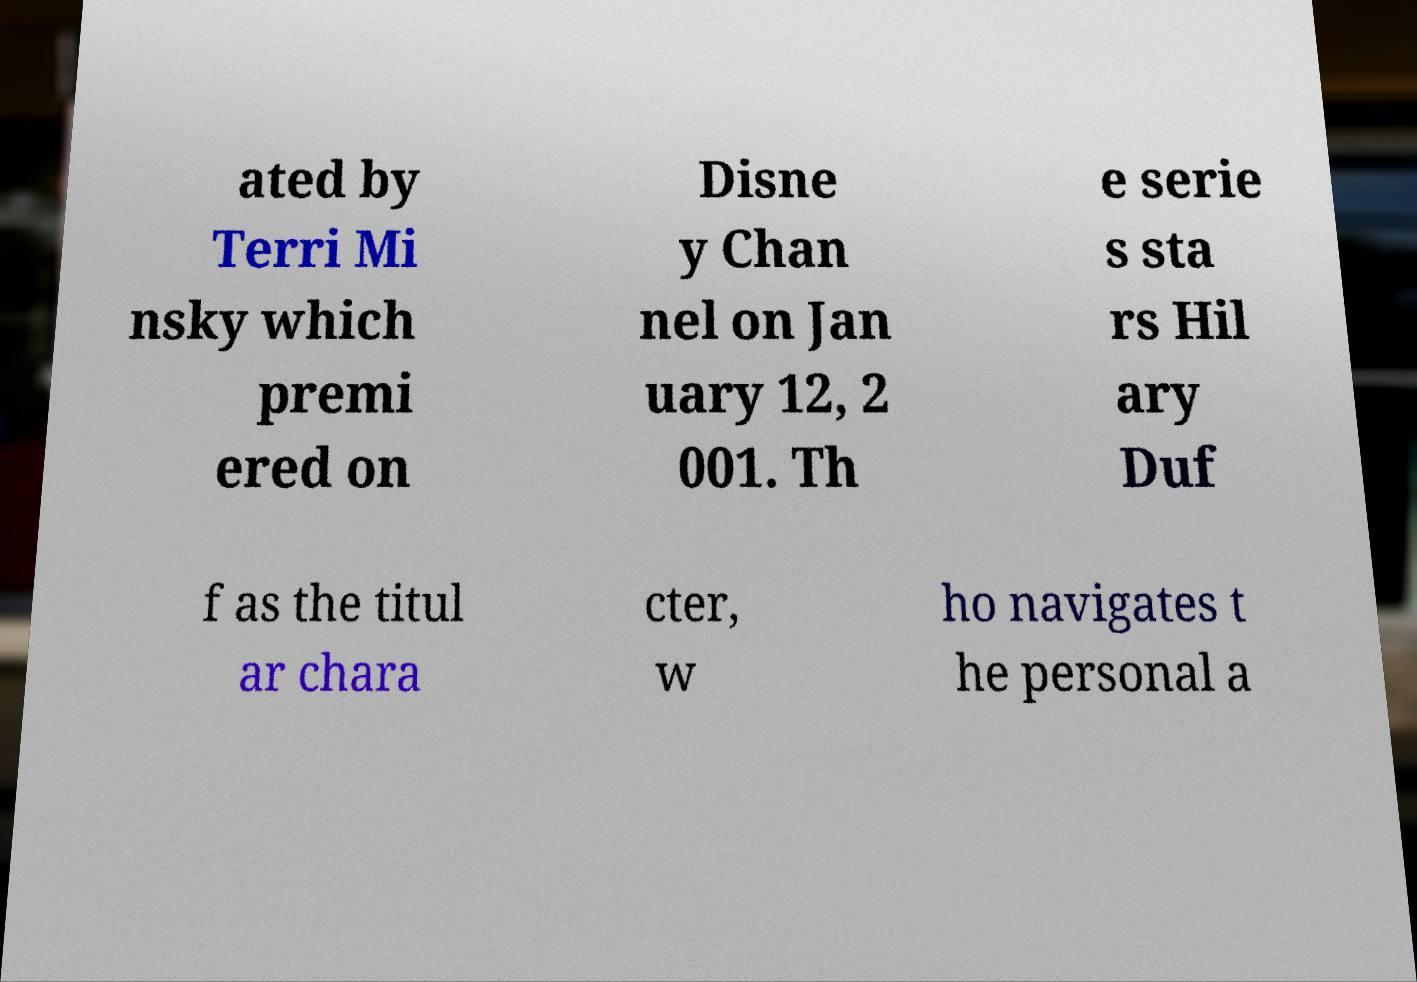Please identify and transcribe the text found in this image. ated by Terri Mi nsky which premi ered on Disne y Chan nel on Jan uary 12, 2 001. Th e serie s sta rs Hil ary Duf f as the titul ar chara cter, w ho navigates t he personal a 